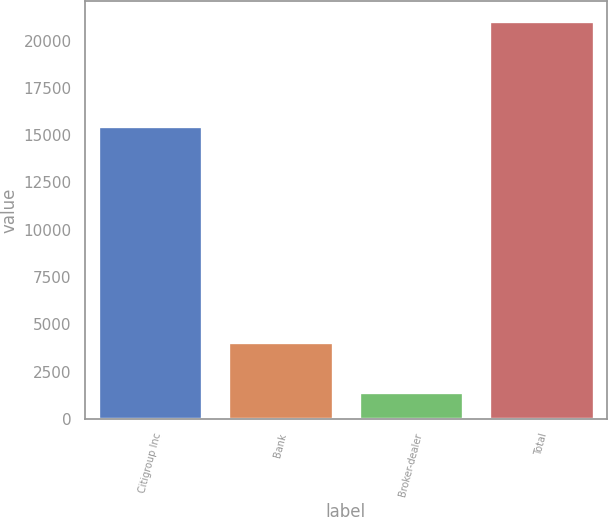Convert chart to OTSL. <chart><loc_0><loc_0><loc_500><loc_500><bar_chart><fcel>Citigroup Inc<fcel>Bank<fcel>Broker-dealer<fcel>Total<nl><fcel>15499<fcel>4077<fcel>1443<fcel>21019<nl></chart> 